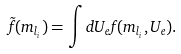<formula> <loc_0><loc_0><loc_500><loc_500>\tilde { f } ( m _ { l _ { i } } ) = \int d U _ { e } f ( m _ { l _ { i } } , U _ { e } ) .</formula> 